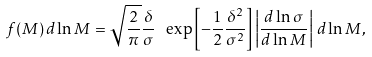<formula> <loc_0><loc_0><loc_500><loc_500>f ( M ) \, d \ln M = \sqrt { \frac { 2 } { \pi } } \frac { \delta } { \sigma } \ \exp \left [ - \frac { 1 } { 2 } \frac { \delta ^ { 2 } } { \sigma ^ { 2 } } \right ] \left | \frac { d \ln \sigma } { d \ln M } \right | \, d \ln M ,</formula> 